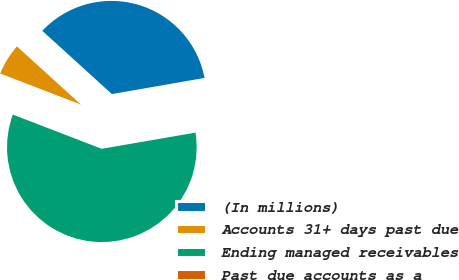Convert chart to OTSL. <chart><loc_0><loc_0><loc_500><loc_500><pie_chart><fcel>(In millions)<fcel>Accounts 31+ days past due<fcel>Ending managed receivables<fcel>Past due accounts as a<nl><fcel>35.51%<fcel>5.89%<fcel>58.58%<fcel>0.03%<nl></chart> 